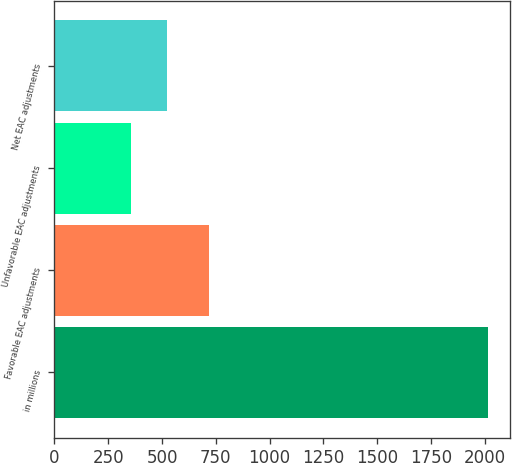<chart> <loc_0><loc_0><loc_500><loc_500><bar_chart><fcel>in millions<fcel>Favorable EAC adjustments<fcel>Unfavorable EAC adjustments<fcel>Net EAC adjustments<nl><fcel>2017<fcel>717<fcel>357<fcel>523<nl></chart> 